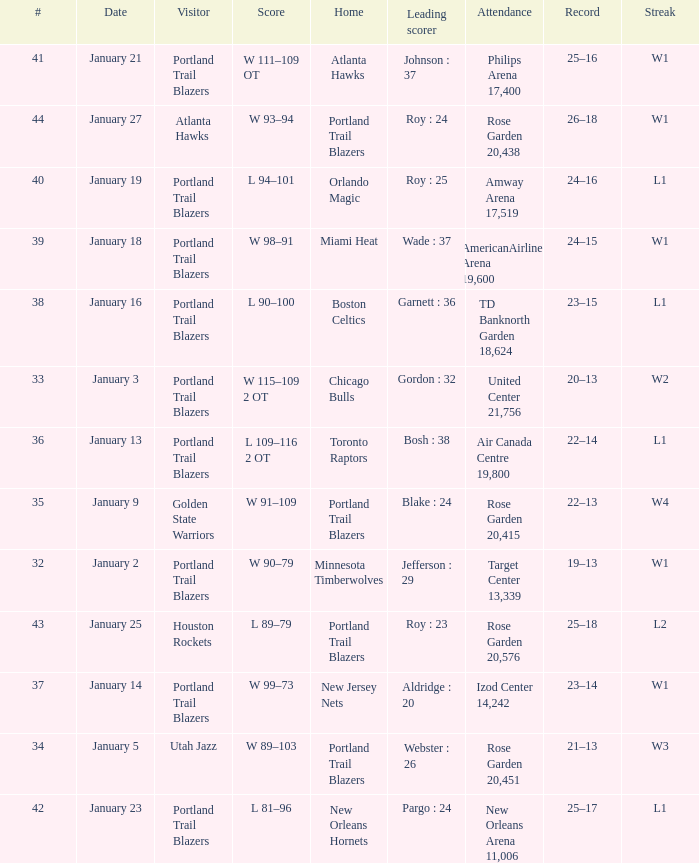Which visitors have a leading scorer of roy : 25 Portland Trail Blazers. 